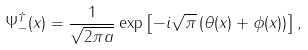Convert formula to latex. <formula><loc_0><loc_0><loc_500><loc_500>\Psi ^ { \dagger } _ { - } ( x ) = \frac { 1 } { \sqrt { 2 \pi a } } \exp \left [ - i \sqrt { \pi } \left ( \theta ( x ) + \phi ( x ) \right ) \right ] ,</formula> 